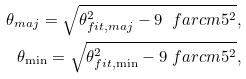Convert formula to latex. <formula><loc_0><loc_0><loc_500><loc_500>\theta _ { m a j } = \sqrt { \theta _ { f i t , m a j } ^ { 2 } - 9 \ f a r c m 5 ^ { 2 } } , \\ \theta _ { \min } = \sqrt { \theta _ { f i t , \min } ^ { 2 } - 9 \ f a r c m 5 ^ { 2 } } ,</formula> 